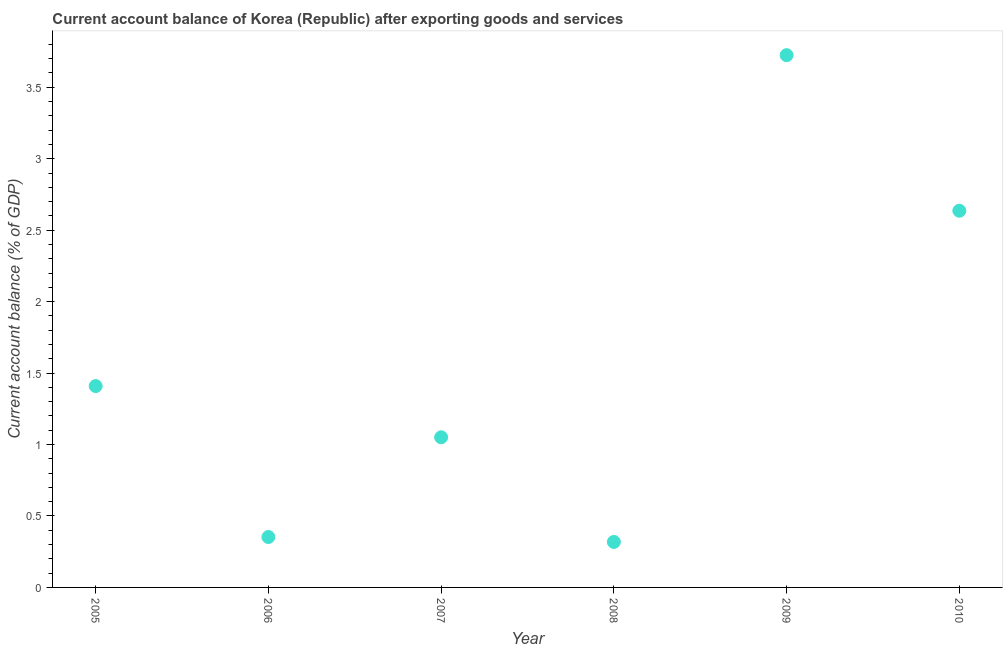What is the current account balance in 2008?
Your answer should be compact. 0.32. Across all years, what is the maximum current account balance?
Make the answer very short. 3.72. Across all years, what is the minimum current account balance?
Make the answer very short. 0.32. In which year was the current account balance maximum?
Ensure brevity in your answer.  2009. What is the sum of the current account balance?
Keep it short and to the point. 9.49. What is the difference between the current account balance in 2007 and 2008?
Offer a very short reply. 0.73. What is the average current account balance per year?
Provide a short and direct response. 1.58. What is the median current account balance?
Offer a terse response. 1.23. In how many years, is the current account balance greater than 1.7 %?
Provide a short and direct response. 2. What is the ratio of the current account balance in 2008 to that in 2010?
Your answer should be very brief. 0.12. Is the current account balance in 2006 less than that in 2007?
Offer a very short reply. Yes. What is the difference between the highest and the second highest current account balance?
Make the answer very short. 1.09. What is the difference between the highest and the lowest current account balance?
Give a very brief answer. 3.41. Does the current account balance monotonically increase over the years?
Your answer should be compact. No. How many dotlines are there?
Give a very brief answer. 1. What is the difference between two consecutive major ticks on the Y-axis?
Offer a terse response. 0.5. Are the values on the major ticks of Y-axis written in scientific E-notation?
Your answer should be compact. No. Does the graph contain grids?
Provide a succinct answer. No. What is the title of the graph?
Give a very brief answer. Current account balance of Korea (Republic) after exporting goods and services. What is the label or title of the Y-axis?
Provide a succinct answer. Current account balance (% of GDP). What is the Current account balance (% of GDP) in 2005?
Your answer should be very brief. 1.41. What is the Current account balance (% of GDP) in 2006?
Provide a short and direct response. 0.35. What is the Current account balance (% of GDP) in 2007?
Offer a very short reply. 1.05. What is the Current account balance (% of GDP) in 2008?
Your answer should be compact. 0.32. What is the Current account balance (% of GDP) in 2009?
Your answer should be very brief. 3.72. What is the Current account balance (% of GDP) in 2010?
Provide a succinct answer. 2.64. What is the difference between the Current account balance (% of GDP) in 2005 and 2006?
Offer a terse response. 1.06. What is the difference between the Current account balance (% of GDP) in 2005 and 2007?
Give a very brief answer. 0.36. What is the difference between the Current account balance (% of GDP) in 2005 and 2008?
Provide a succinct answer. 1.09. What is the difference between the Current account balance (% of GDP) in 2005 and 2009?
Offer a very short reply. -2.32. What is the difference between the Current account balance (% of GDP) in 2005 and 2010?
Provide a short and direct response. -1.23. What is the difference between the Current account balance (% of GDP) in 2006 and 2007?
Your response must be concise. -0.7. What is the difference between the Current account balance (% of GDP) in 2006 and 2008?
Your answer should be compact. 0.03. What is the difference between the Current account balance (% of GDP) in 2006 and 2009?
Your answer should be compact. -3.37. What is the difference between the Current account balance (% of GDP) in 2006 and 2010?
Provide a short and direct response. -2.28. What is the difference between the Current account balance (% of GDP) in 2007 and 2008?
Ensure brevity in your answer.  0.73. What is the difference between the Current account balance (% of GDP) in 2007 and 2009?
Your response must be concise. -2.67. What is the difference between the Current account balance (% of GDP) in 2007 and 2010?
Your response must be concise. -1.59. What is the difference between the Current account balance (% of GDP) in 2008 and 2009?
Ensure brevity in your answer.  -3.41. What is the difference between the Current account balance (% of GDP) in 2008 and 2010?
Provide a succinct answer. -2.32. What is the difference between the Current account balance (% of GDP) in 2009 and 2010?
Offer a very short reply. 1.09. What is the ratio of the Current account balance (% of GDP) in 2005 to that in 2006?
Offer a terse response. 3.99. What is the ratio of the Current account balance (% of GDP) in 2005 to that in 2007?
Provide a succinct answer. 1.34. What is the ratio of the Current account balance (% of GDP) in 2005 to that in 2008?
Keep it short and to the point. 4.43. What is the ratio of the Current account balance (% of GDP) in 2005 to that in 2009?
Provide a short and direct response. 0.38. What is the ratio of the Current account balance (% of GDP) in 2005 to that in 2010?
Your response must be concise. 0.54. What is the ratio of the Current account balance (% of GDP) in 2006 to that in 2007?
Make the answer very short. 0.34. What is the ratio of the Current account balance (% of GDP) in 2006 to that in 2008?
Make the answer very short. 1.11. What is the ratio of the Current account balance (% of GDP) in 2006 to that in 2009?
Provide a succinct answer. 0.1. What is the ratio of the Current account balance (% of GDP) in 2006 to that in 2010?
Your response must be concise. 0.13. What is the ratio of the Current account balance (% of GDP) in 2007 to that in 2008?
Give a very brief answer. 3.3. What is the ratio of the Current account balance (% of GDP) in 2007 to that in 2009?
Keep it short and to the point. 0.28. What is the ratio of the Current account balance (% of GDP) in 2007 to that in 2010?
Provide a succinct answer. 0.4. What is the ratio of the Current account balance (% of GDP) in 2008 to that in 2009?
Your answer should be compact. 0.09. What is the ratio of the Current account balance (% of GDP) in 2008 to that in 2010?
Provide a short and direct response. 0.12. What is the ratio of the Current account balance (% of GDP) in 2009 to that in 2010?
Provide a short and direct response. 1.41. 